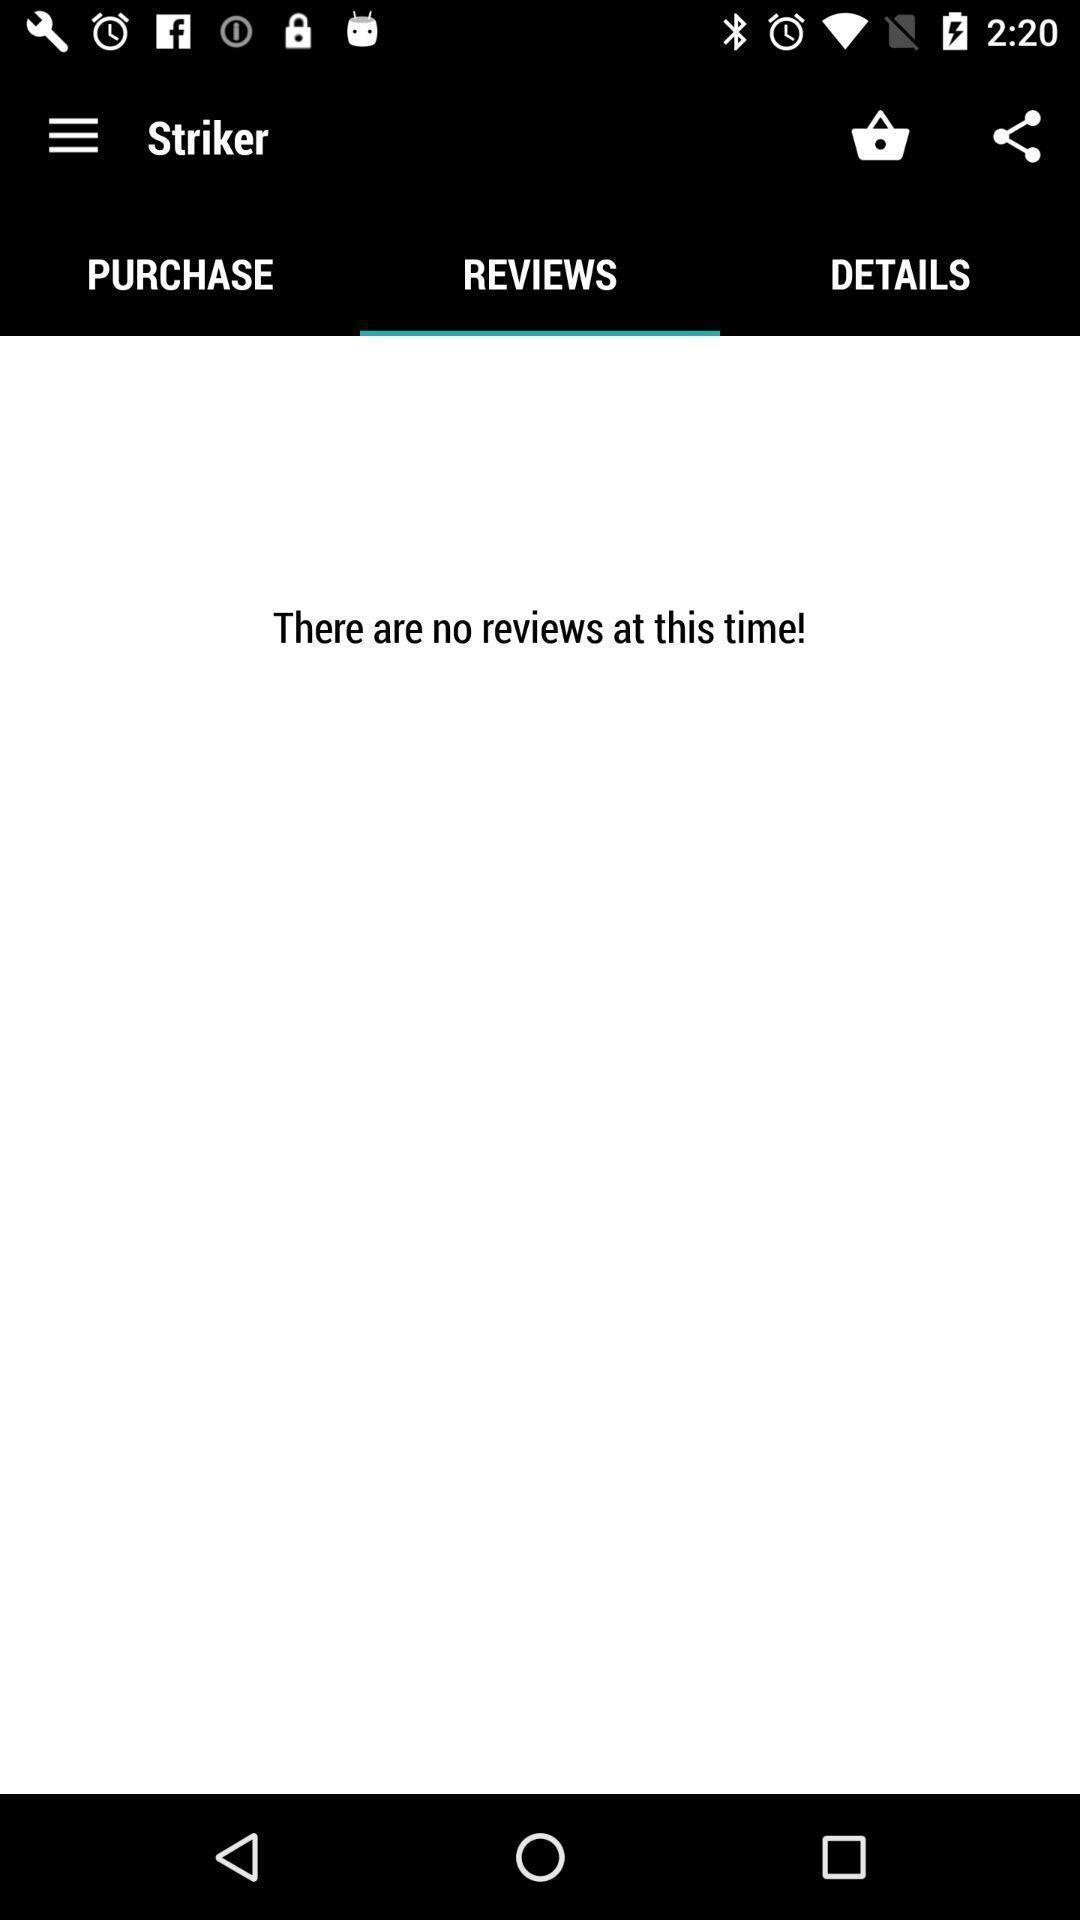Please provide a description for this image. Screen showing reviews page. 